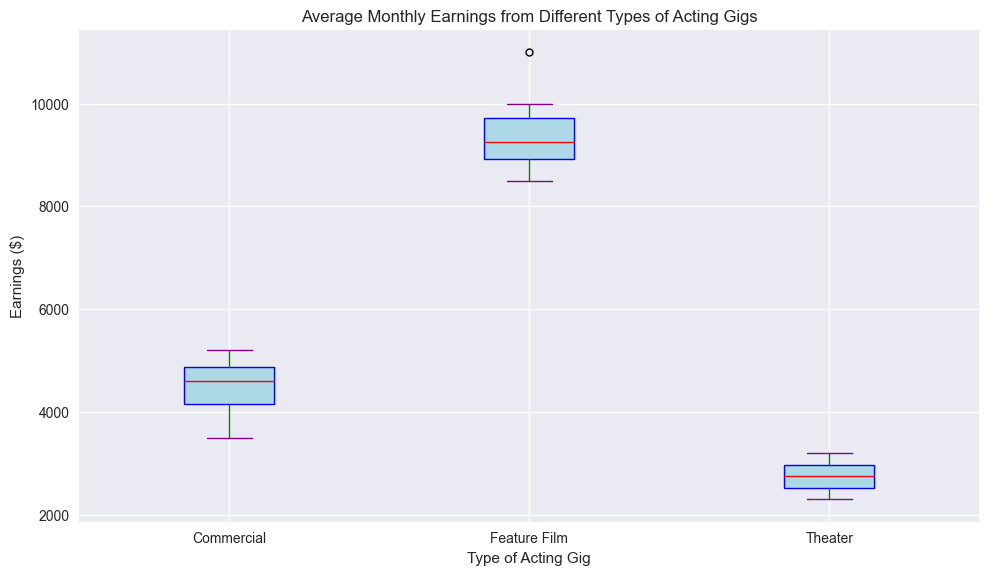What's the median earnings for commercials? To find the median earnings for commercials in the box plot, locate the line within the box for 'Commercials.' This line indicates the median value.
Answer: 4550 Which type of acting gig has the highest median earnings? Compare the median lines across the boxes for Commercials, Feature Films, and Theater. The box with the highest median line represents the type with the highest median earnings.
Answer: Feature Film Which type of acting gig has the largest range of earnings? The range is determined by the distance between the lower and upper whiskers. Comparing the lengths of the whiskers, the type with the longest whiskers has the largest range.
Answer: Feature Film Is the interquartile range (IQR) for Theater earnings larger than the IQR for Commercials? IQR is the distance between the bottom and top of the box. Compare the height of the boxes for Theater and Commercials to see which has a larger IQR.
Answer: No Which type of acting gig shows more variability in earnings, Commercials or Theater? Variability can be assessed by looking at the spread of the entire boxplot including the whiskers and any outliers. Compare the spread for both Commercials and Theater to determine which has more variability.
Answer: Commercials Are there any outliers in the earnings for Feature Films? Outliers in box plots are often represented by individual points outside the whiskers. Check if there are such points for Feature Films.
Answer: No What is the median earnings difference between Feature Films and Theater? Locate the median lines for both Feature Films and Theater. Measure the difference between these two lines to find the median earnings difference.
Answer: 6700 How do the upper whiskers of Theater and Commercial earnings compare? The upper whiskers show the maximum within the interquartile range min and max. Compare the upper whisker for Theater and Commercial to see which is higher.
Answer: Commercial What type of acting gig has the smallest interquartile range (IQR)? The IQR is shown by the height of the box. Determine which type of acting gig has the smallest box to answer this.
Answer: Commercial If you are aiming for consistently higher pay, which type of acting gig should you target? For consistently higher pay, look at the median and the range of earnings. A higher and tighter median and range indicate more consistent pay.
Answer: Feature Film 